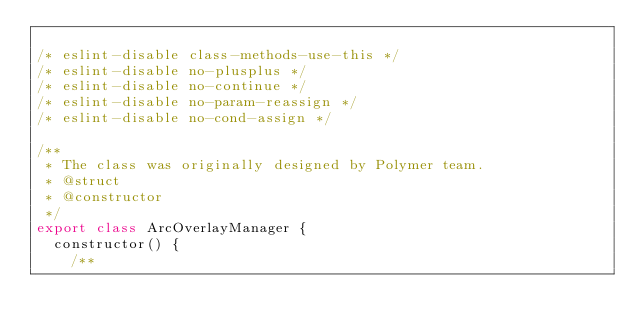Convert code to text. <code><loc_0><loc_0><loc_500><loc_500><_JavaScript_>
/* eslint-disable class-methods-use-this */
/* eslint-disable no-plusplus */
/* eslint-disable no-continue */
/* eslint-disable no-param-reassign */
/* eslint-disable no-cond-assign */

/**
 * The class was originally designed by Polymer team.
 * @struct
 * @constructor
 */
export class ArcOverlayManager {
  constructor() {
    /**</code> 